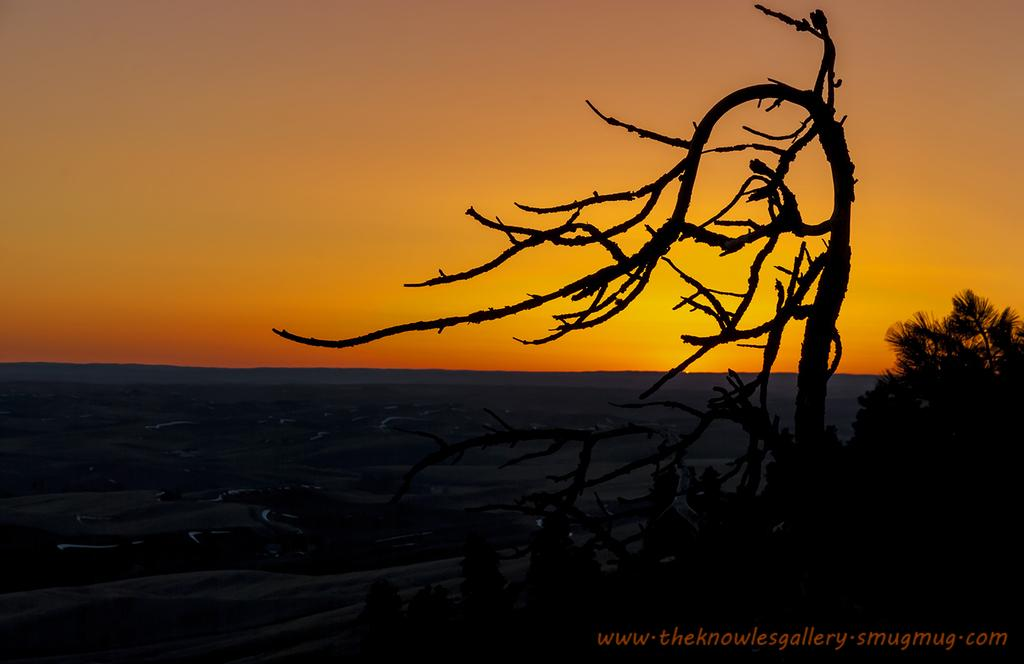What can be observed about the image's appearance? The image appears to be edited. What is located at the bottom of the image? There is text at the bottom of the image. What type of vegetation is present in the image? There are trees and branches visible in the image. What natural elements can be seen in the image? There is water and sky visible in the image. Can you tell me how many icicles are hanging from the branches in the image? There are no icicles present in the image; only trees and branches are visible. What type of brush is used to create the text at the bottom of the image? The text at the bottom of the image is not handwritten, so there is no brush involved in its creation. 